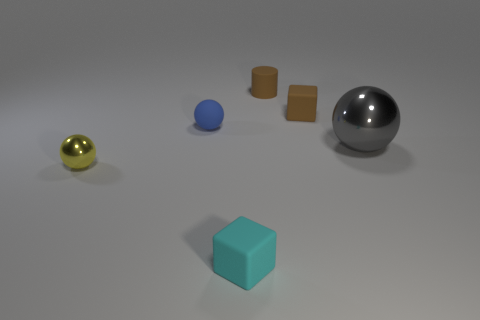Add 3 big gray metallic balls. How many objects exist? 9 Subtract all cylinders. How many objects are left? 5 Add 6 small yellow spheres. How many small yellow spheres are left? 7 Add 2 tiny red shiny cylinders. How many tiny red shiny cylinders exist? 2 Subtract 0 green balls. How many objects are left? 6 Subtract all large gray matte spheres. Subtract all yellow things. How many objects are left? 5 